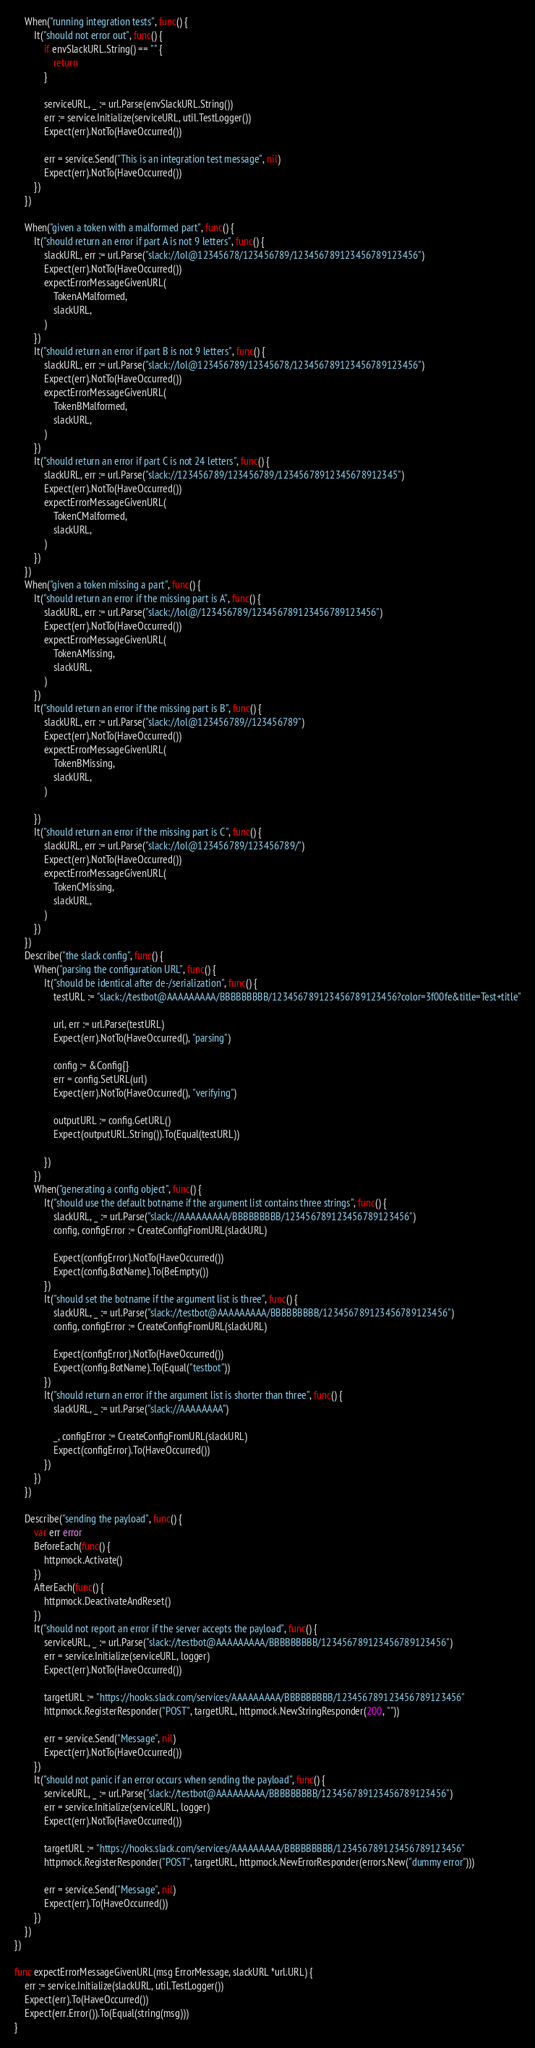<code> <loc_0><loc_0><loc_500><loc_500><_Go_>
	When("running integration tests", func() {
		It("should not error out", func() {
			if envSlackURL.String() == "" {
				return
			}

			serviceURL, _ := url.Parse(envSlackURL.String())
			err := service.Initialize(serviceURL, util.TestLogger())
			Expect(err).NotTo(HaveOccurred())

			err = service.Send("This is an integration test message", nil)
			Expect(err).NotTo(HaveOccurred())
		})
	})

	When("given a token with a malformed part", func() {
		It("should return an error if part A is not 9 letters", func() {
			slackURL, err := url.Parse("slack://lol@12345678/123456789/123456789123456789123456")
			Expect(err).NotTo(HaveOccurred())
			expectErrorMessageGivenURL(
				TokenAMalformed,
				slackURL,
			)
		})
		It("should return an error if part B is not 9 letters", func() {
			slackURL, err := url.Parse("slack://lol@123456789/12345678/123456789123456789123456")
			Expect(err).NotTo(HaveOccurred())
			expectErrorMessageGivenURL(
				TokenBMalformed,
				slackURL,
			)
		})
		It("should return an error if part C is not 24 letters", func() {
			slackURL, err := url.Parse("slack://123456789/123456789/12345678912345678912345")
			Expect(err).NotTo(HaveOccurred())
			expectErrorMessageGivenURL(
				TokenCMalformed,
				slackURL,
			)
		})
	})
	When("given a token missing a part", func() {
		It("should return an error if the missing part is A", func() {
			slackURL, err := url.Parse("slack://lol@/123456789/123456789123456789123456")
			Expect(err).NotTo(HaveOccurred())
			expectErrorMessageGivenURL(
				TokenAMissing,
				slackURL,
			)
		})
		It("should return an error if the missing part is B", func() {
			slackURL, err := url.Parse("slack://lol@123456789//123456789")
			Expect(err).NotTo(HaveOccurred())
			expectErrorMessageGivenURL(
				TokenBMissing,
				slackURL,
			)

		})
		It("should return an error if the missing part is C", func() {
			slackURL, err := url.Parse("slack://lol@123456789/123456789/")
			Expect(err).NotTo(HaveOccurred())
			expectErrorMessageGivenURL(
				TokenCMissing,
				slackURL,
			)
		})
	})
	Describe("the slack config", func() {
		When("parsing the configuration URL", func() {
			It("should be identical after de-/serialization", func() {
				testURL := "slack://testbot@AAAAAAAAA/BBBBBBBBB/123456789123456789123456?color=3f00fe&title=Test+title"

				url, err := url.Parse(testURL)
				Expect(err).NotTo(HaveOccurred(), "parsing")

				config := &Config{}
				err = config.SetURL(url)
				Expect(err).NotTo(HaveOccurred(), "verifying")

				outputURL := config.GetURL()
				Expect(outputURL.String()).To(Equal(testURL))

			})
		})
		When("generating a config object", func() {
			It("should use the default botname if the argument list contains three strings", func() {
				slackURL, _ := url.Parse("slack://AAAAAAAAA/BBBBBBBBB/123456789123456789123456")
				config, configError := CreateConfigFromURL(slackURL)

				Expect(configError).NotTo(HaveOccurred())
				Expect(config.BotName).To(BeEmpty())
			})
			It("should set the botname if the argument list is three", func() {
				slackURL, _ := url.Parse("slack://testbot@AAAAAAAAA/BBBBBBBBB/123456789123456789123456")
				config, configError := CreateConfigFromURL(slackURL)

				Expect(configError).NotTo(HaveOccurred())
				Expect(config.BotName).To(Equal("testbot"))
			})
			It("should return an error if the argument list is shorter than three", func() {
				slackURL, _ := url.Parse("slack://AAAAAAAA")

				_, configError := CreateConfigFromURL(slackURL)
				Expect(configError).To(HaveOccurred())
			})
		})
	})

	Describe("sending the payload", func() {
		var err error
		BeforeEach(func() {
			httpmock.Activate()
		})
		AfterEach(func() {
			httpmock.DeactivateAndReset()
		})
		It("should not report an error if the server accepts the payload", func() {
			serviceURL, _ := url.Parse("slack://testbot@AAAAAAAAA/BBBBBBBBB/123456789123456789123456")
			err = service.Initialize(serviceURL, logger)
			Expect(err).NotTo(HaveOccurred())

			targetURL := "https://hooks.slack.com/services/AAAAAAAAA/BBBBBBBBB/123456789123456789123456"
			httpmock.RegisterResponder("POST", targetURL, httpmock.NewStringResponder(200, ""))

			err = service.Send("Message", nil)
			Expect(err).NotTo(HaveOccurred())
		})
		It("should not panic if an error occurs when sending the payload", func() {
			serviceURL, _ := url.Parse("slack://testbot@AAAAAAAAA/BBBBBBBBB/123456789123456789123456")
			err = service.Initialize(serviceURL, logger)
			Expect(err).NotTo(HaveOccurred())

			targetURL := "https://hooks.slack.com/services/AAAAAAAAA/BBBBBBBBB/123456789123456789123456"
			httpmock.RegisterResponder("POST", targetURL, httpmock.NewErrorResponder(errors.New("dummy error")))

			err = service.Send("Message", nil)
			Expect(err).To(HaveOccurred())
		})
	})
})

func expectErrorMessageGivenURL(msg ErrorMessage, slackURL *url.URL) {
	err := service.Initialize(slackURL, util.TestLogger())
	Expect(err).To(HaveOccurred())
	Expect(err.Error()).To(Equal(string(msg)))
}
</code> 